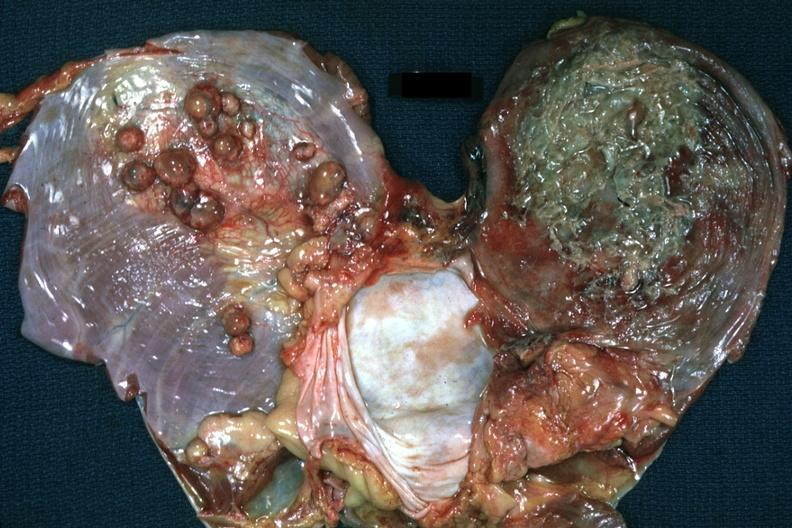what does this image show?
Answer the question using a single word or phrase. Both leaves of diaphragm one covered by purulent exudate and the other with multiple tumor nodules 